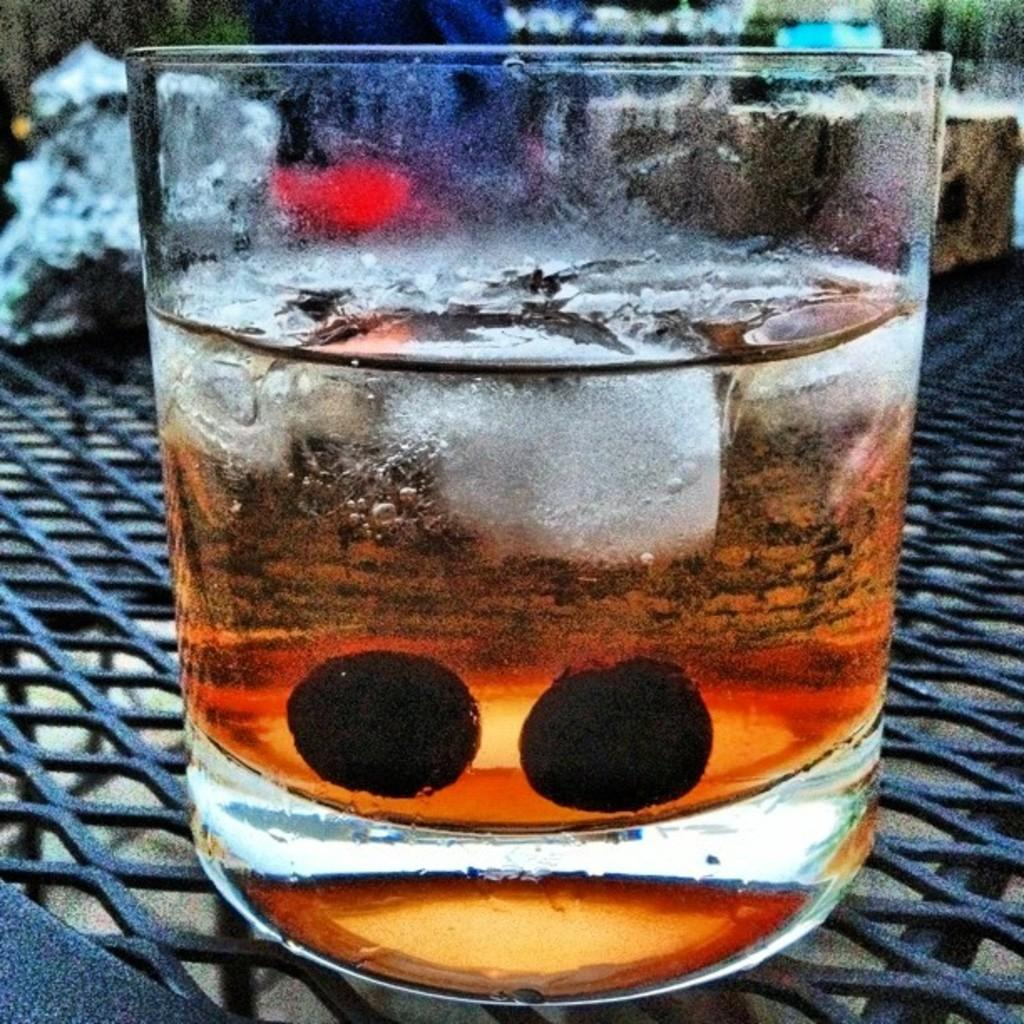What is inside the glass that is visible in the image? There is a drink with ice cubes in the glass. What is the glass placed on in the image? The glass is placed on a mesh. What can be seen in the background of the image? There are blurry objects in the background of the image. What type of weather can be seen in the image? There is no indication of weather in the image, as it is focused on a glass with a drink and a mesh surface. 